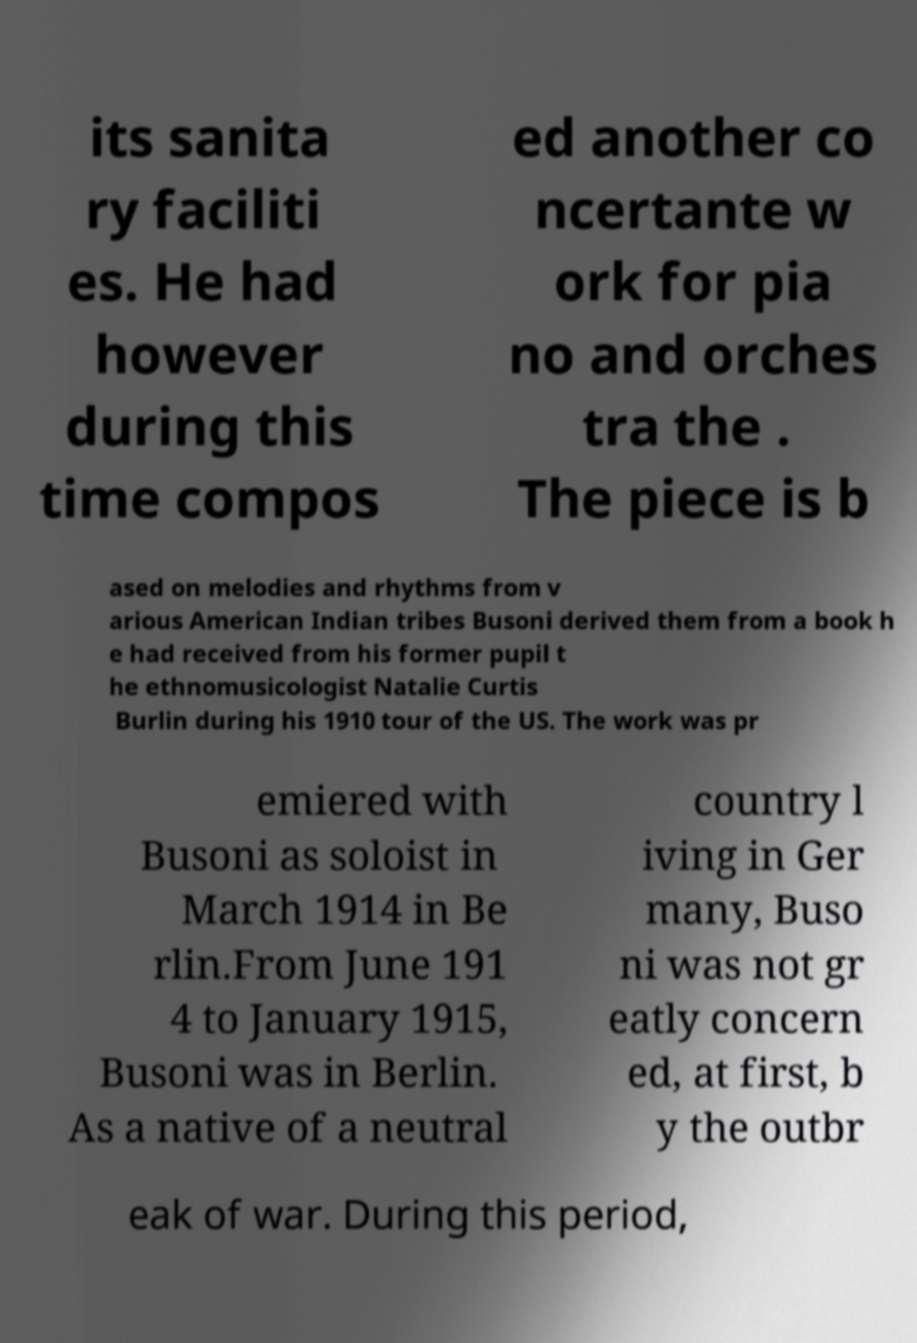Can you accurately transcribe the text from the provided image for me? its sanita ry faciliti es. He had however during this time compos ed another co ncertante w ork for pia no and orches tra the . The piece is b ased on melodies and rhythms from v arious American Indian tribes Busoni derived them from a book h e had received from his former pupil t he ethnomusicologist Natalie Curtis Burlin during his 1910 tour of the US. The work was pr emiered with Busoni as soloist in March 1914 in Be rlin.From June 191 4 to January 1915, Busoni was in Berlin. As a native of a neutral country l iving in Ger many, Buso ni was not gr eatly concern ed, at first, b y the outbr eak of war. During this period, 